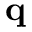<formula> <loc_0><loc_0><loc_500><loc_500>q</formula> 